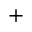Convert formula to latex. <formula><loc_0><loc_0><loc_500><loc_500>^ { + }</formula> 